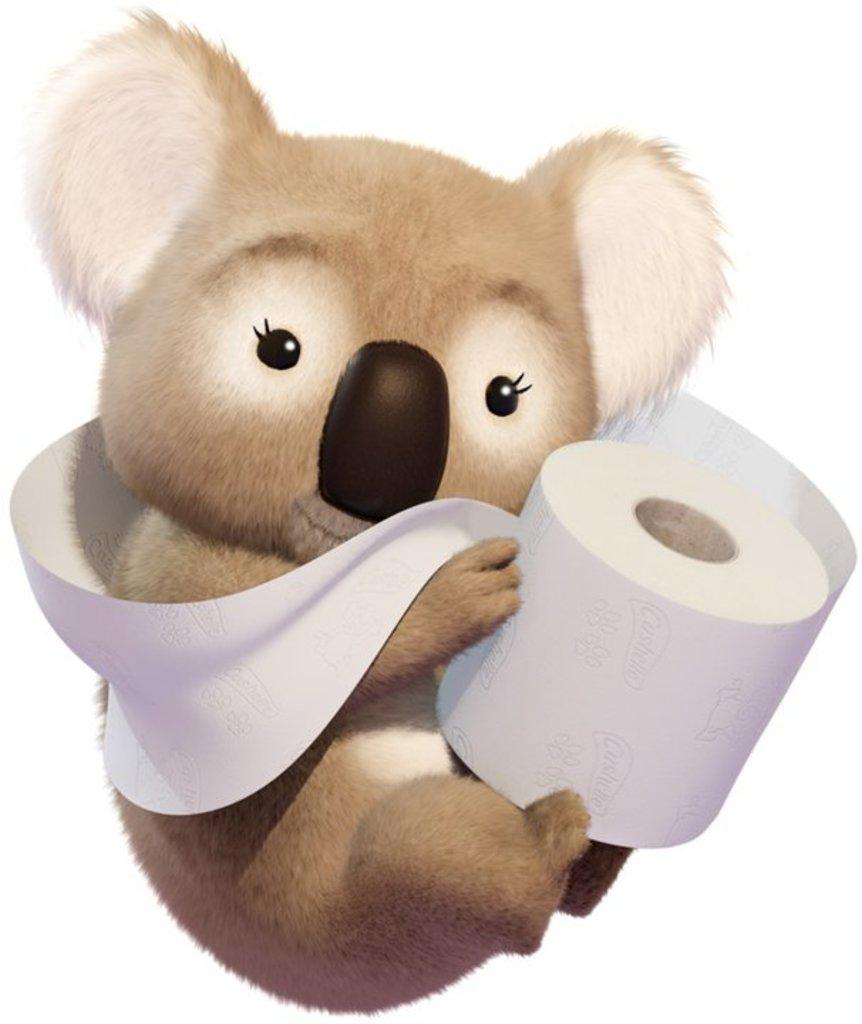What is the main subject of the image? There is an animal depicted in the image. What is the animal doing in the image? The animal is holding a roll of paper. What color is the background of the image? The background of the image is white. Reasoning: Let' Let's think step by step in order to produce the conversation. We start by identifying the main subject of the image, which is the animal. Then, we describe the action of the animal, which is holding a roll of paper. Finally, we mention the color of the background, which is white. Absurd Question/Answer: What type of bells can be heard ringing in the image? There are no bells present in the image, and therefore no sound can be heard. How does the animal use the quartz in the image? There is no quartz present in the image, so the animal cannot use it. What type of bells can be heard ringing in the image? There are no bells present in the image, and therefore no sound can be heard. How does the animal use the quartz in the image? There is no quartz present in the image, so the animal cannot use it. 